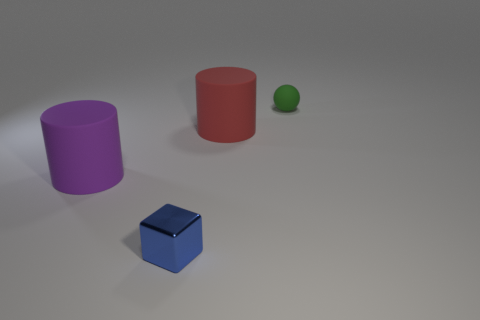Can you tell me about the lighting and shadows present in the image? The lighting in the image seems to come from an upper corner, casting soft-edged shadows that extend towards the right. The lighter shadow of the sphere suggests the light source isn't overly direct. How does the lighting affect the mood of the image? The subtle lighting and soft shadows create a calm, ambient atmosphere, emphasizing the simplicity and clarity of the shapes. 